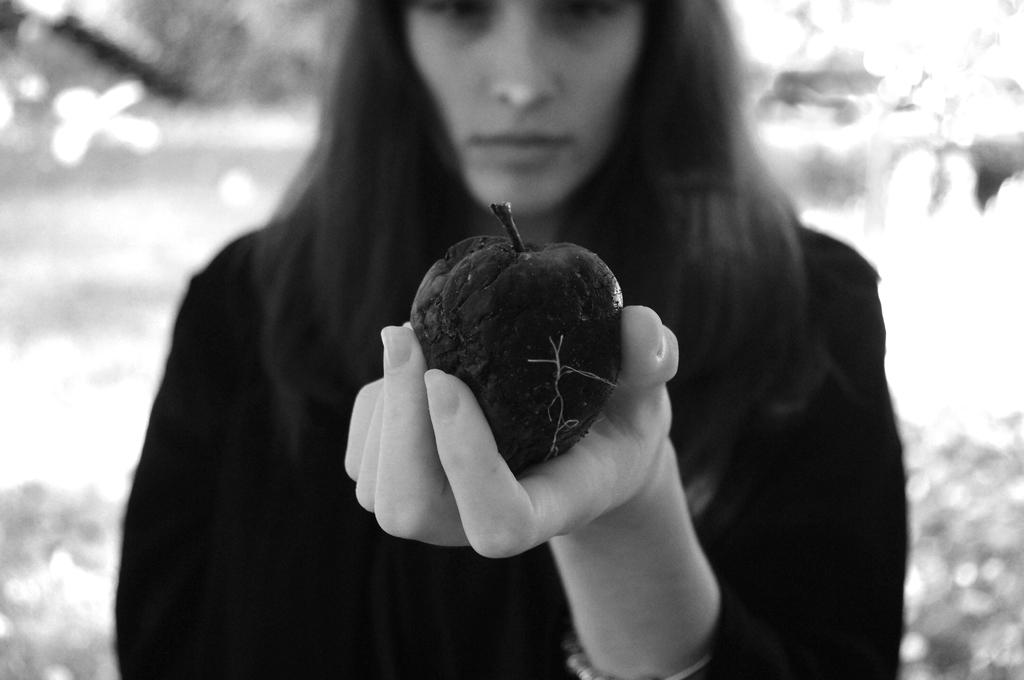What is the color scheme of the image? The image is black and white. Can you describe the main subject in the image? There is a person in the image. What is the person holding in the image? The person is holding a rotten apple. How would you describe the background of the image? The background of the image is blurred. How many chickens are visible in the image? There are no chickens present in the image. What type of body is shown in the image? The image only features a person, and there is no other body visible. Can you tell me the credit score of the person in the image? There is no information about the person's credit score in the image. 